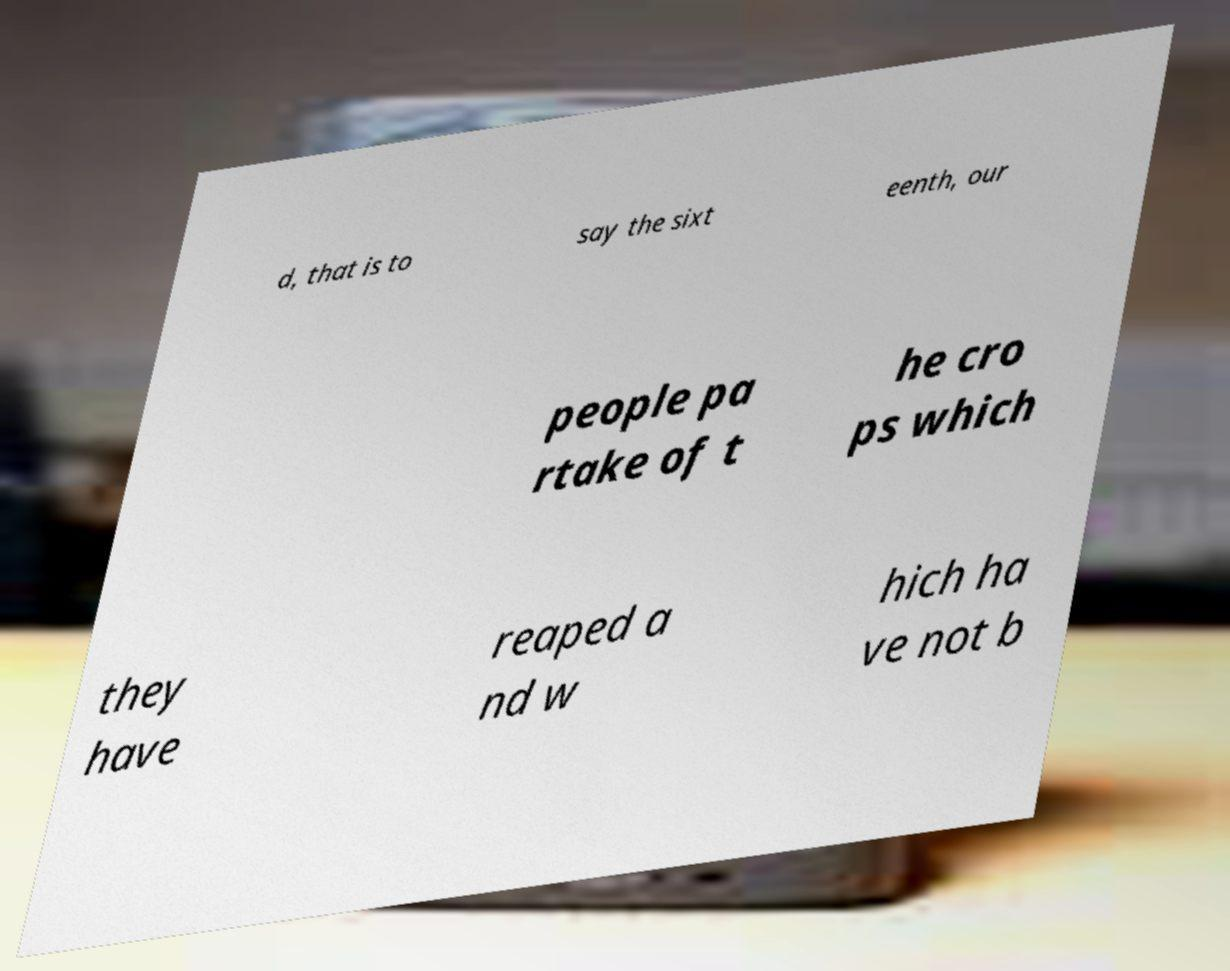Please read and relay the text visible in this image. What does it say? d, that is to say the sixt eenth, our people pa rtake of t he cro ps which they have reaped a nd w hich ha ve not b 